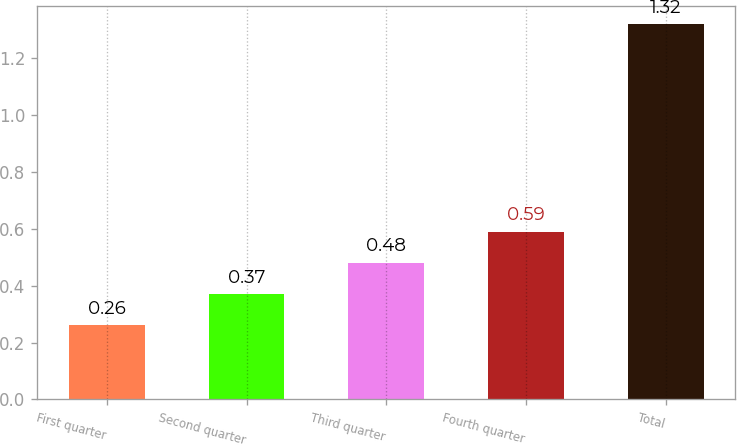Convert chart to OTSL. <chart><loc_0><loc_0><loc_500><loc_500><bar_chart><fcel>First quarter<fcel>Second quarter<fcel>Third quarter<fcel>Fourth quarter<fcel>Total<nl><fcel>0.26<fcel>0.37<fcel>0.48<fcel>0.59<fcel>1.32<nl></chart> 